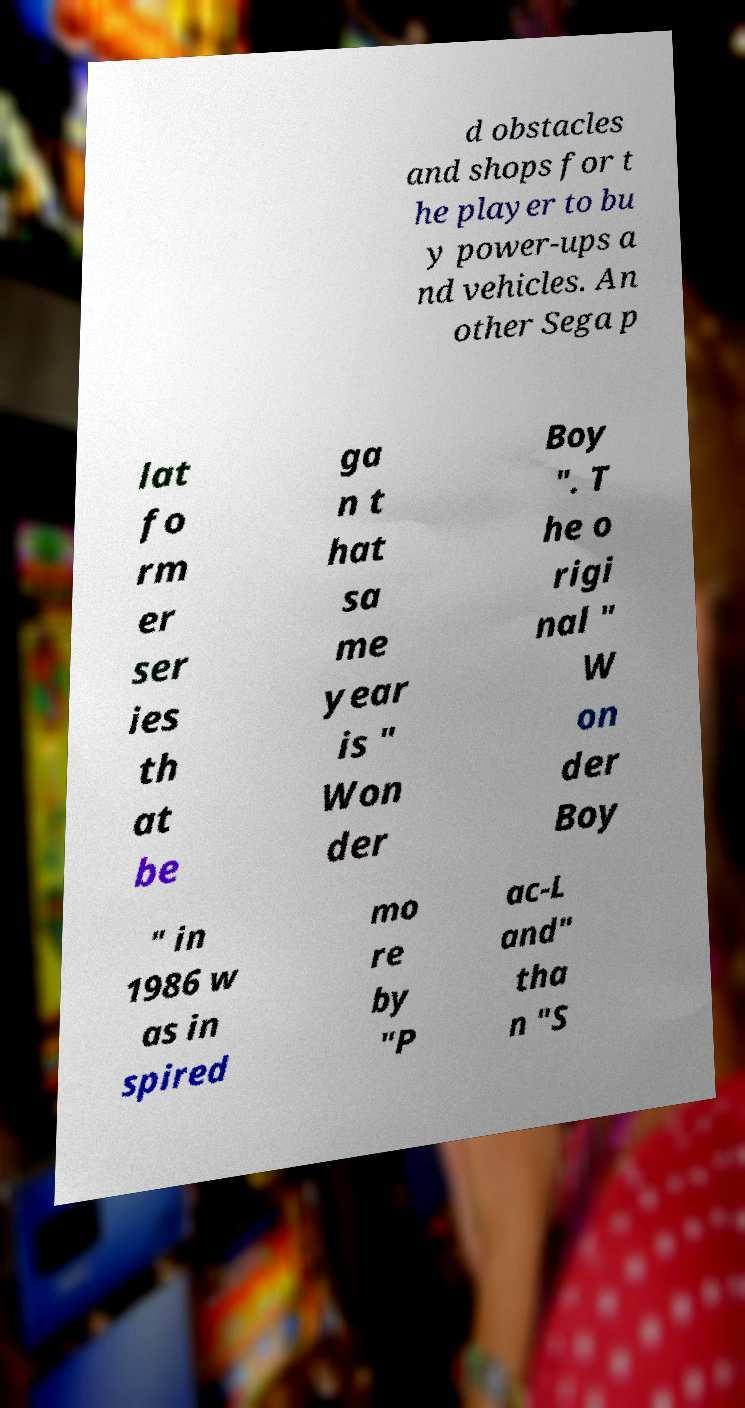Can you accurately transcribe the text from the provided image for me? d obstacles and shops for t he player to bu y power-ups a nd vehicles. An other Sega p lat fo rm er ser ies th at be ga n t hat sa me year is " Won der Boy ". T he o rigi nal " W on der Boy " in 1986 w as in spired mo re by "P ac-L and" tha n "S 